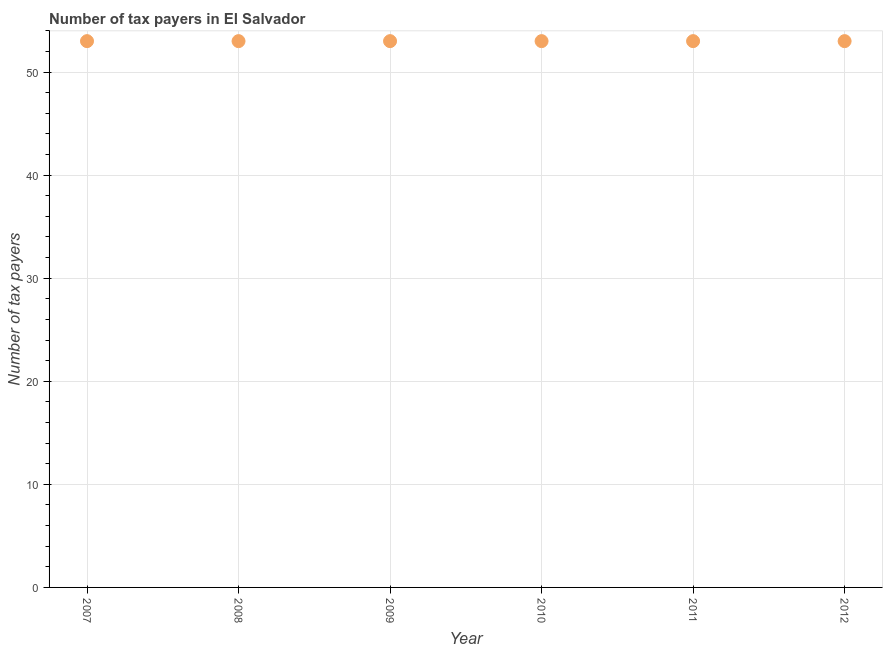What is the number of tax payers in 2011?
Keep it short and to the point. 53. Across all years, what is the maximum number of tax payers?
Offer a very short reply. 53. Across all years, what is the minimum number of tax payers?
Your response must be concise. 53. In which year was the number of tax payers maximum?
Provide a succinct answer. 2007. What is the sum of the number of tax payers?
Your answer should be compact. 318. What is the difference between the number of tax payers in 2009 and 2010?
Provide a short and direct response. 0. What is the median number of tax payers?
Your response must be concise. 53. In how many years, is the number of tax payers greater than 46 ?
Make the answer very short. 6. What is the ratio of the number of tax payers in 2008 to that in 2012?
Provide a succinct answer. 1. Are the values on the major ticks of Y-axis written in scientific E-notation?
Ensure brevity in your answer.  No. What is the title of the graph?
Your response must be concise. Number of tax payers in El Salvador. What is the label or title of the X-axis?
Your answer should be very brief. Year. What is the label or title of the Y-axis?
Keep it short and to the point. Number of tax payers. What is the Number of tax payers in 2007?
Your answer should be very brief. 53. What is the Number of tax payers in 2008?
Keep it short and to the point. 53. What is the Number of tax payers in 2010?
Provide a short and direct response. 53. What is the Number of tax payers in 2011?
Your answer should be very brief. 53. What is the difference between the Number of tax payers in 2007 and 2008?
Your answer should be very brief. 0. What is the difference between the Number of tax payers in 2007 and 2011?
Offer a terse response. 0. What is the difference between the Number of tax payers in 2009 and 2010?
Ensure brevity in your answer.  0. What is the difference between the Number of tax payers in 2009 and 2011?
Your answer should be compact. 0. What is the difference between the Number of tax payers in 2009 and 2012?
Provide a succinct answer. 0. What is the ratio of the Number of tax payers in 2007 to that in 2008?
Your response must be concise. 1. What is the ratio of the Number of tax payers in 2007 to that in 2010?
Offer a very short reply. 1. What is the ratio of the Number of tax payers in 2007 to that in 2011?
Ensure brevity in your answer.  1. What is the ratio of the Number of tax payers in 2008 to that in 2009?
Ensure brevity in your answer.  1. What is the ratio of the Number of tax payers in 2009 to that in 2010?
Your answer should be compact. 1. What is the ratio of the Number of tax payers in 2009 to that in 2011?
Your answer should be very brief. 1. What is the ratio of the Number of tax payers in 2010 to that in 2012?
Offer a terse response. 1. 